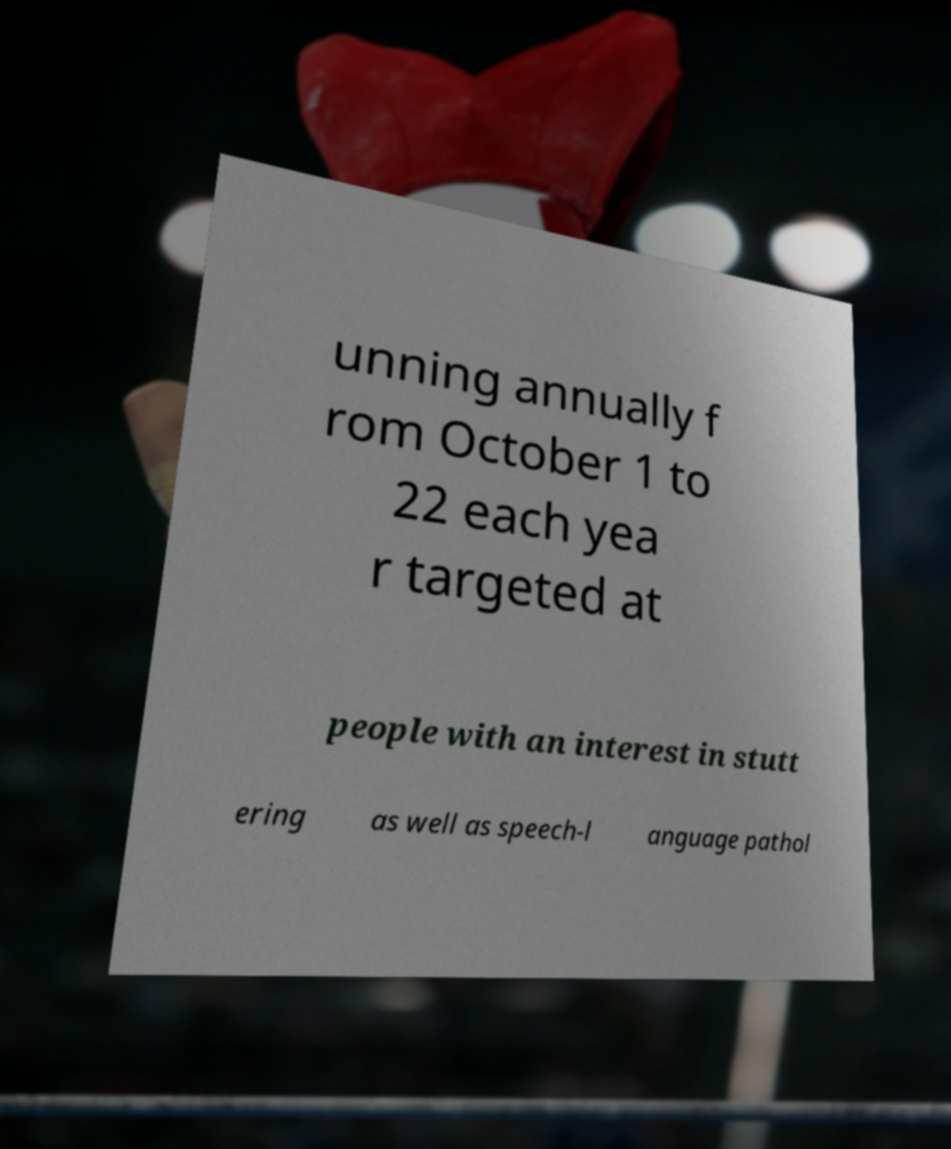There's text embedded in this image that I need extracted. Can you transcribe it verbatim? unning annually f rom October 1 to 22 each yea r targeted at people with an interest in stutt ering as well as speech-l anguage pathol 